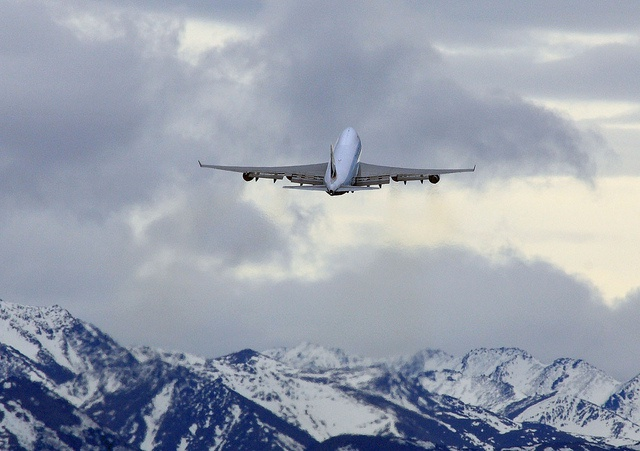Describe the objects in this image and their specific colors. I can see a airplane in darkgray and gray tones in this image. 